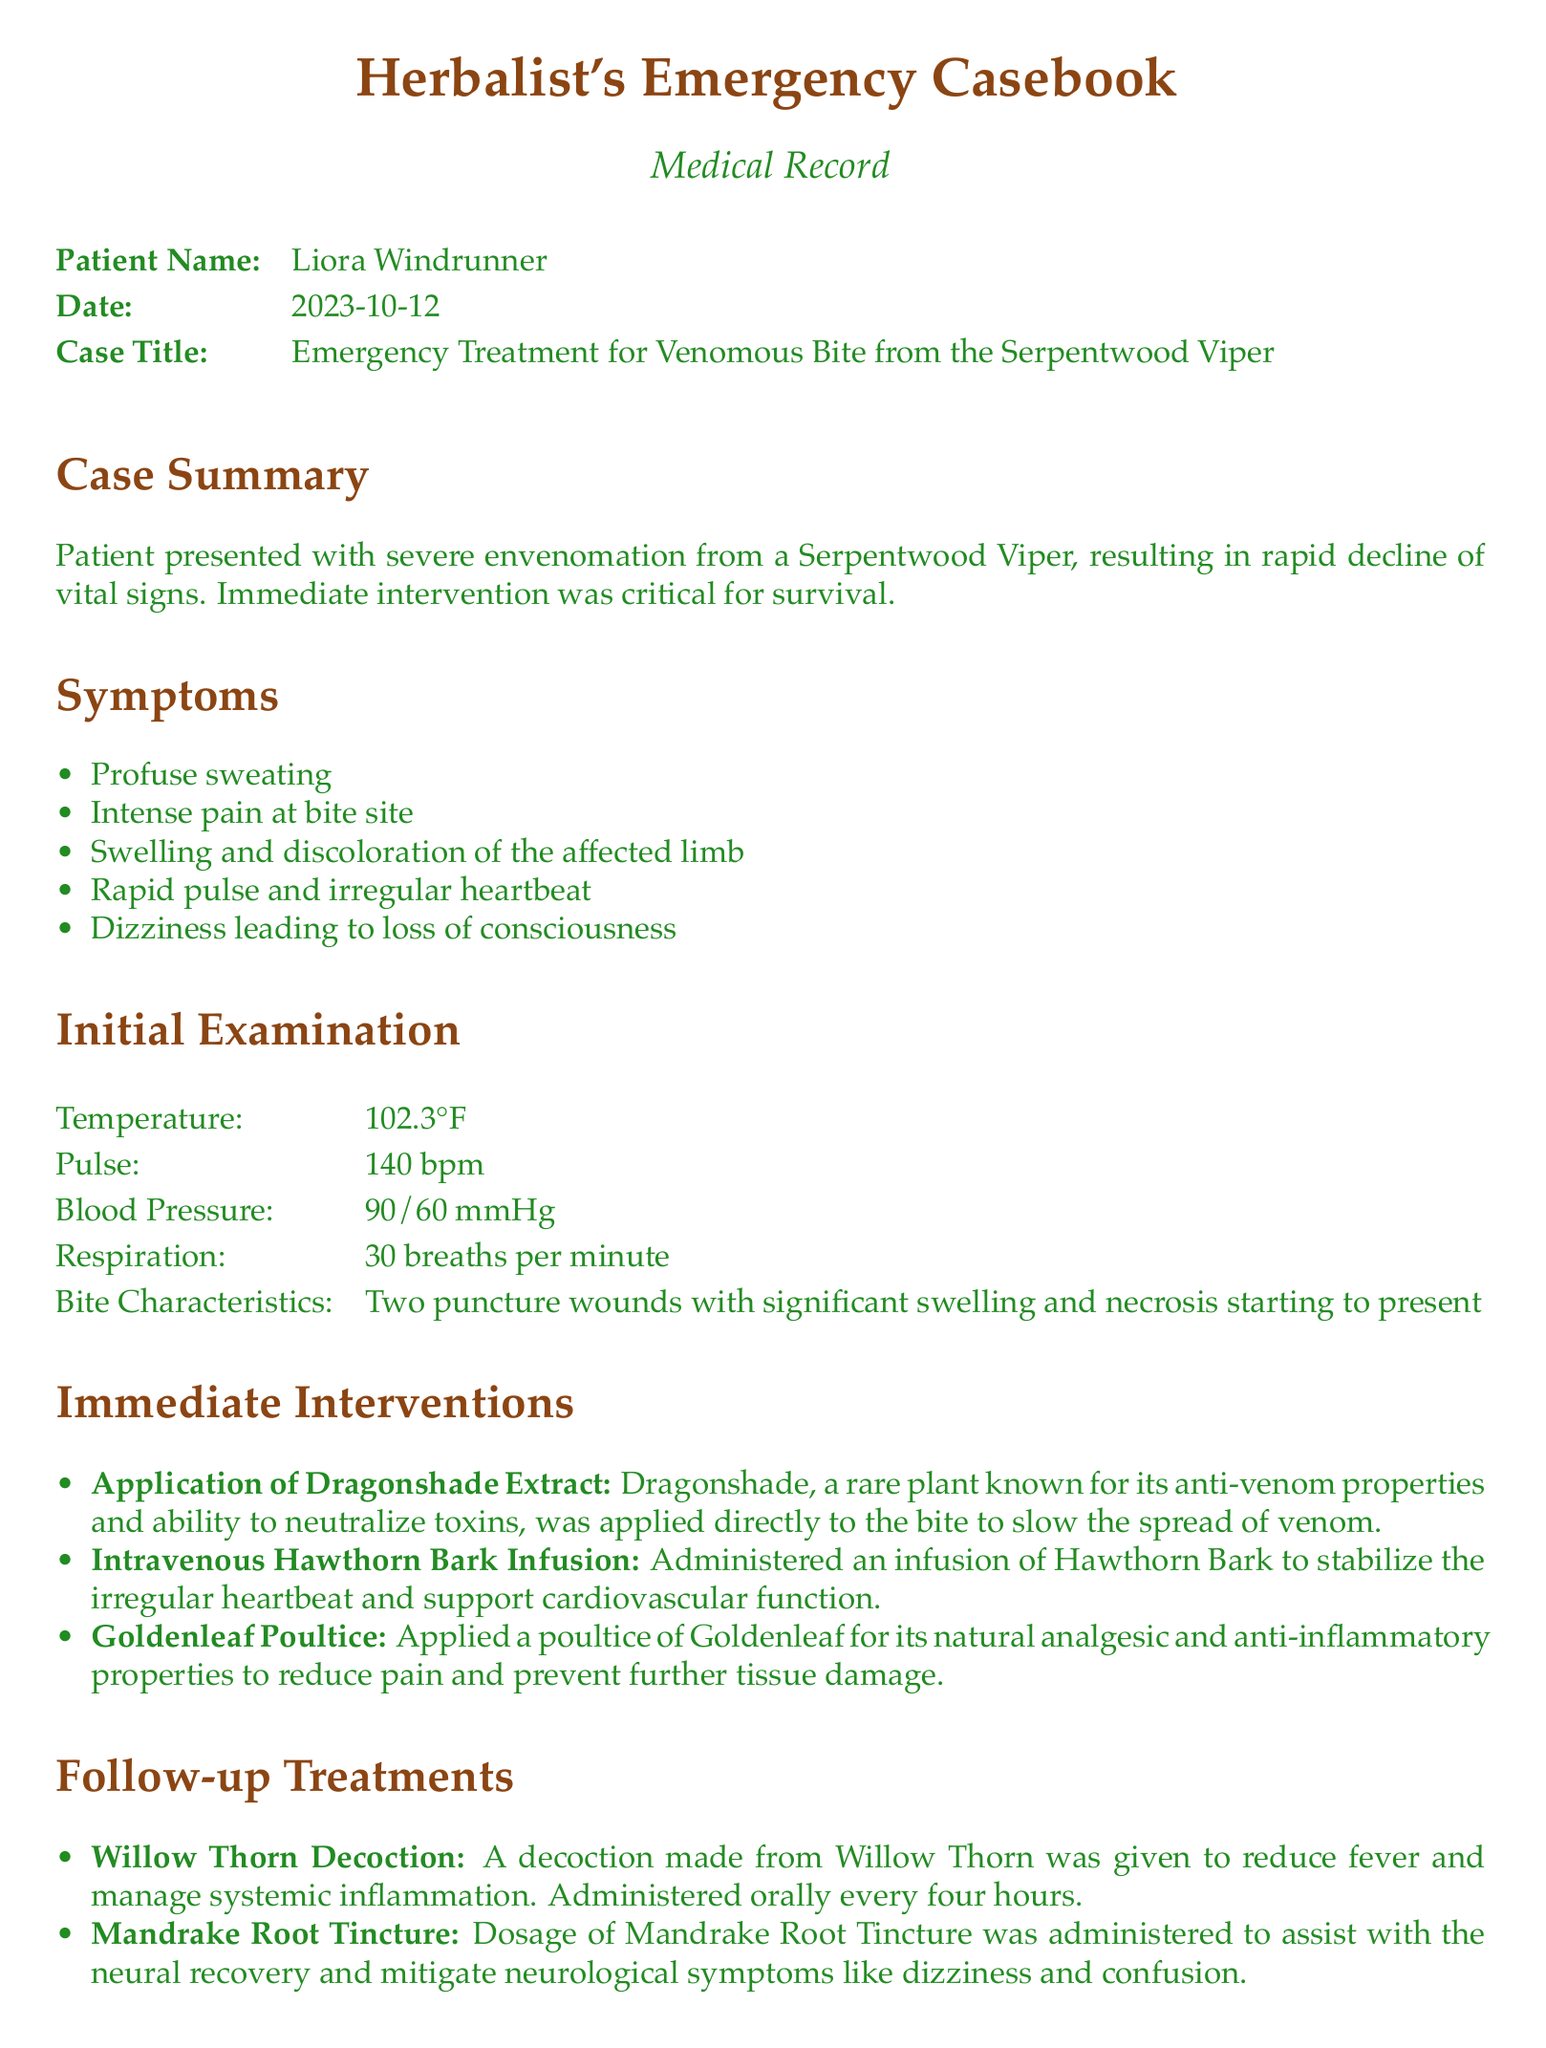What is the patient's name? The patient's name is provided in the document as part of the medical record header.
Answer: Liora Windrunner What date was the case documented? The date is listed in the header section of the document.
Answer: 2023-10-12 What is the title of this case? The case title is specified in the medical record, indicating the nature of the emergency treatment provided.
Answer: Emergency Treatment for Venomous Bite from the Serpentwood Viper What was the patient's pulse rate during the initial examination? The pulse rate is recorded as part of the initial examination section of the document.
Answer: 140 bpm Which extract was applied directly to the bite? The document details immediate interventions, specifying the extract used at the bite site.
Answer: Dragonshade Extract What symptom did the patient experience following the venomous bite? Symptoms are listed in an itemized format, detailing the patient's condition.
Answer: Intense pain at bite site What is the short-term prognosis for the patient? The prognosis section provides a summary of the patient's condition after intervention, specifically denoting the expected outcome.
Answer: Stabilized within the first 24 hours What was administered to assist with neural recovery? The follow-up treatments describe the interventions aimed at alleviating specific symptoms related to the poison.
Answer: Mandrake Root Tincture What type of medical document is this? The document is categorized based on its structure and content relating to medical cases.
Answer: Medical Record 